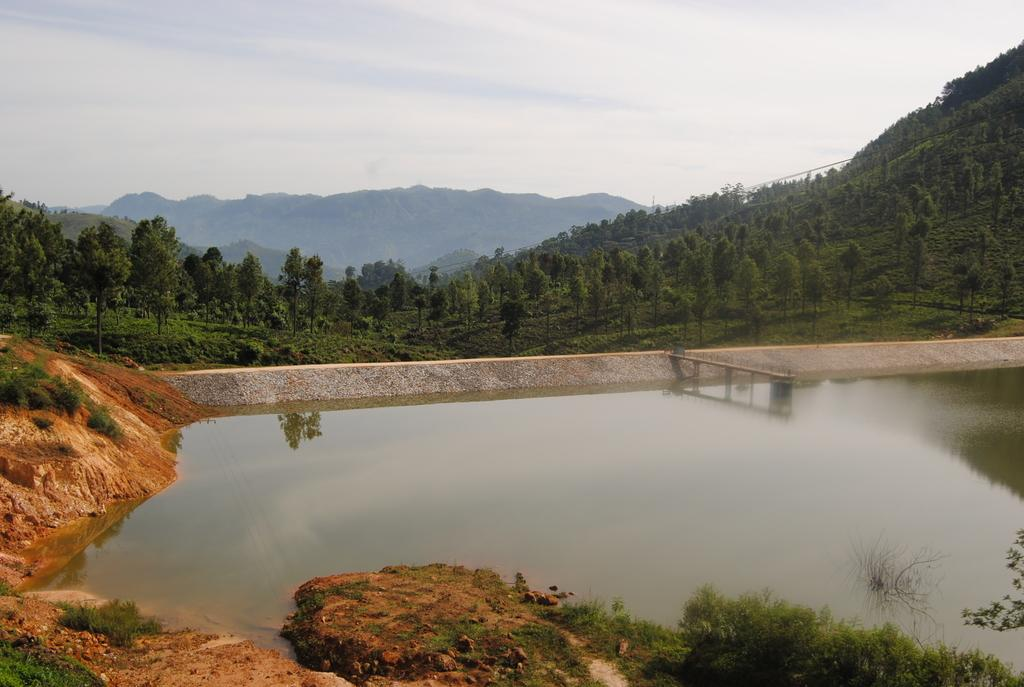What is the texture of the surface in the image? There is a muddy texture in the image. What type of vegetation can be seen at the bottom of the image? There is greenery at the bottom side of the image. What is present in the image besides the greenery? There is water, a dock, trees, mountains, and the sky visible in the image. Where is the dock located in the image? The dock is in the center of the image. What can be seen in the background of the image? There are trees, mountains, and the sky visible in the background of the image. What type of skin condition can be seen on the rat in the image? There is no rat present in the image, and therefore no skin condition can be observed. Who is the friend that can be seen in the image? There is no person or friend depicted in the image. 